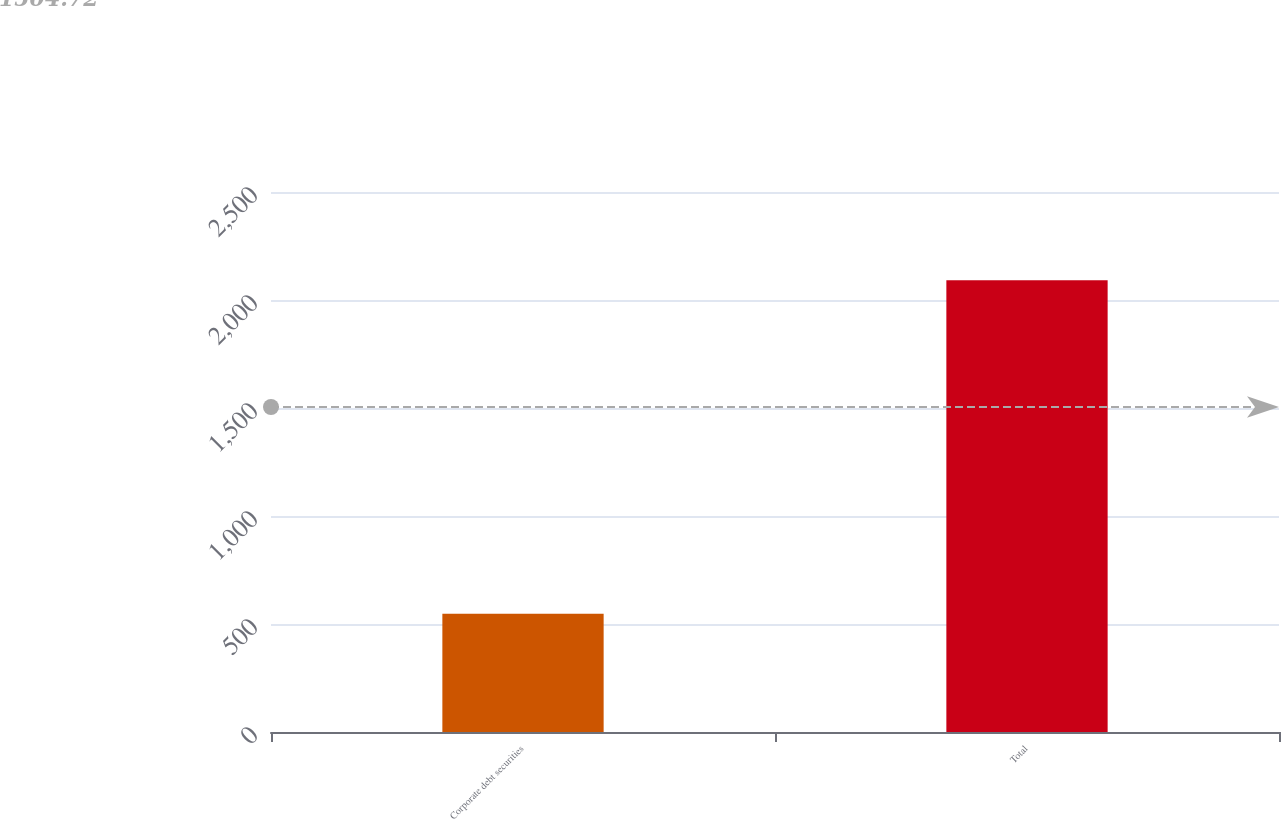Convert chart. <chart><loc_0><loc_0><loc_500><loc_500><bar_chart><fcel>Corporate debt securities<fcel>Total<nl><fcel>547<fcel>2091<nl></chart> 